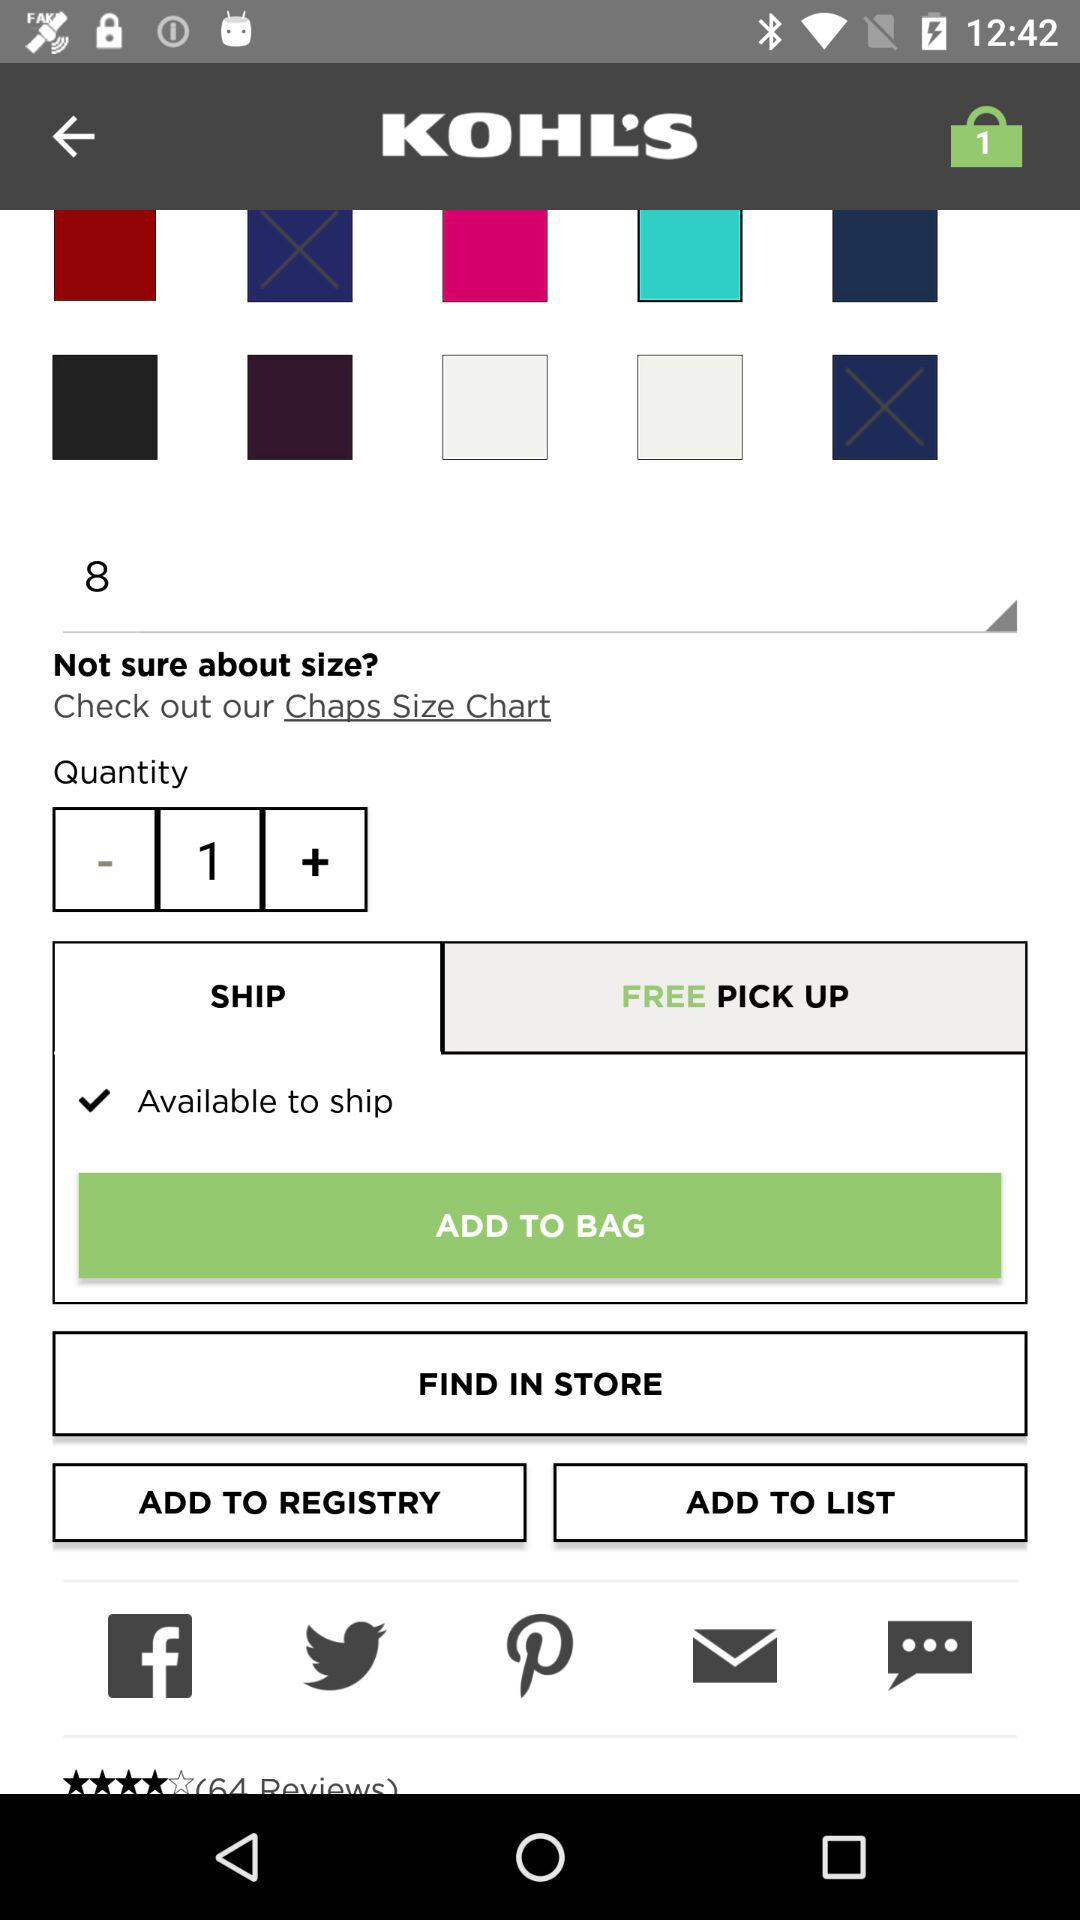What is the number of items in the bag? The number of items in the bag is 1. 